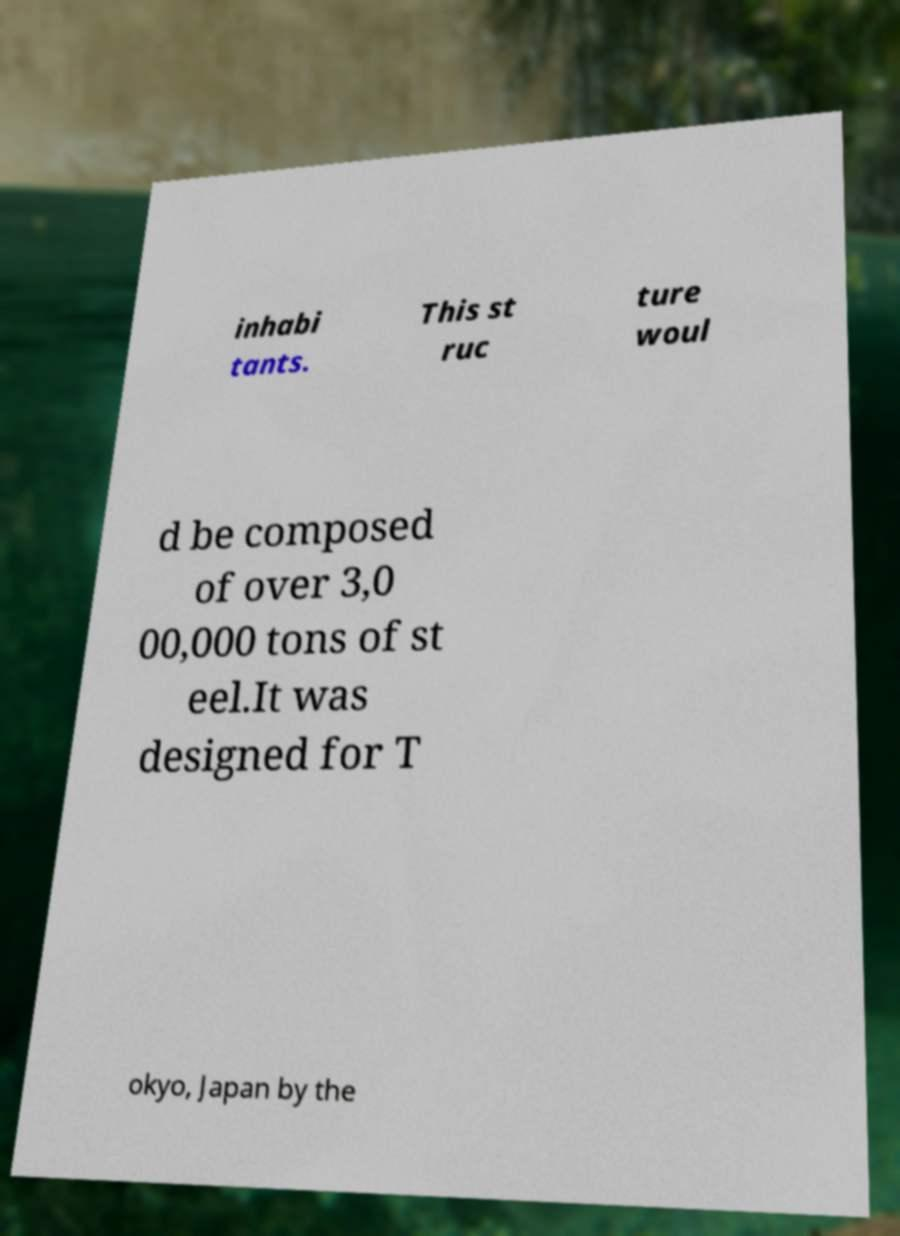Can you accurately transcribe the text from the provided image for me? inhabi tants. This st ruc ture woul d be composed of over 3,0 00,000 tons of st eel.It was designed for T okyo, Japan by the 